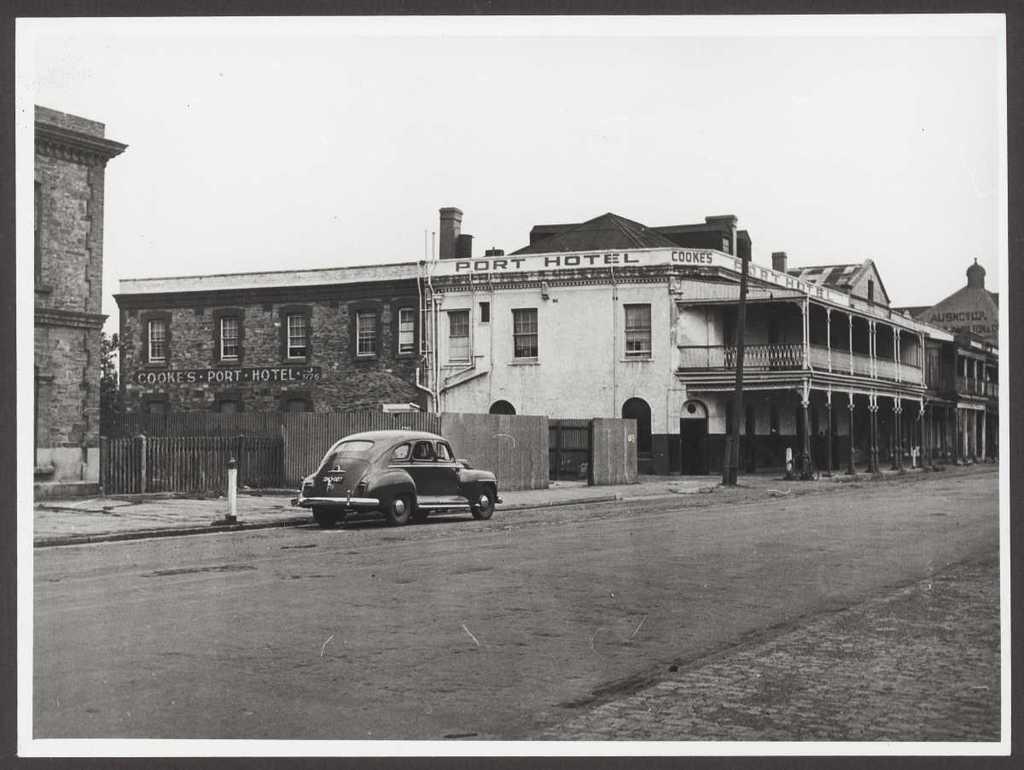Describe this image in one or two sentences. In this image in the center there is a car which is black in colour on the road. In the background there are buildings and there is a fence. On the wall of the building which is in the center there is some text written on it. 